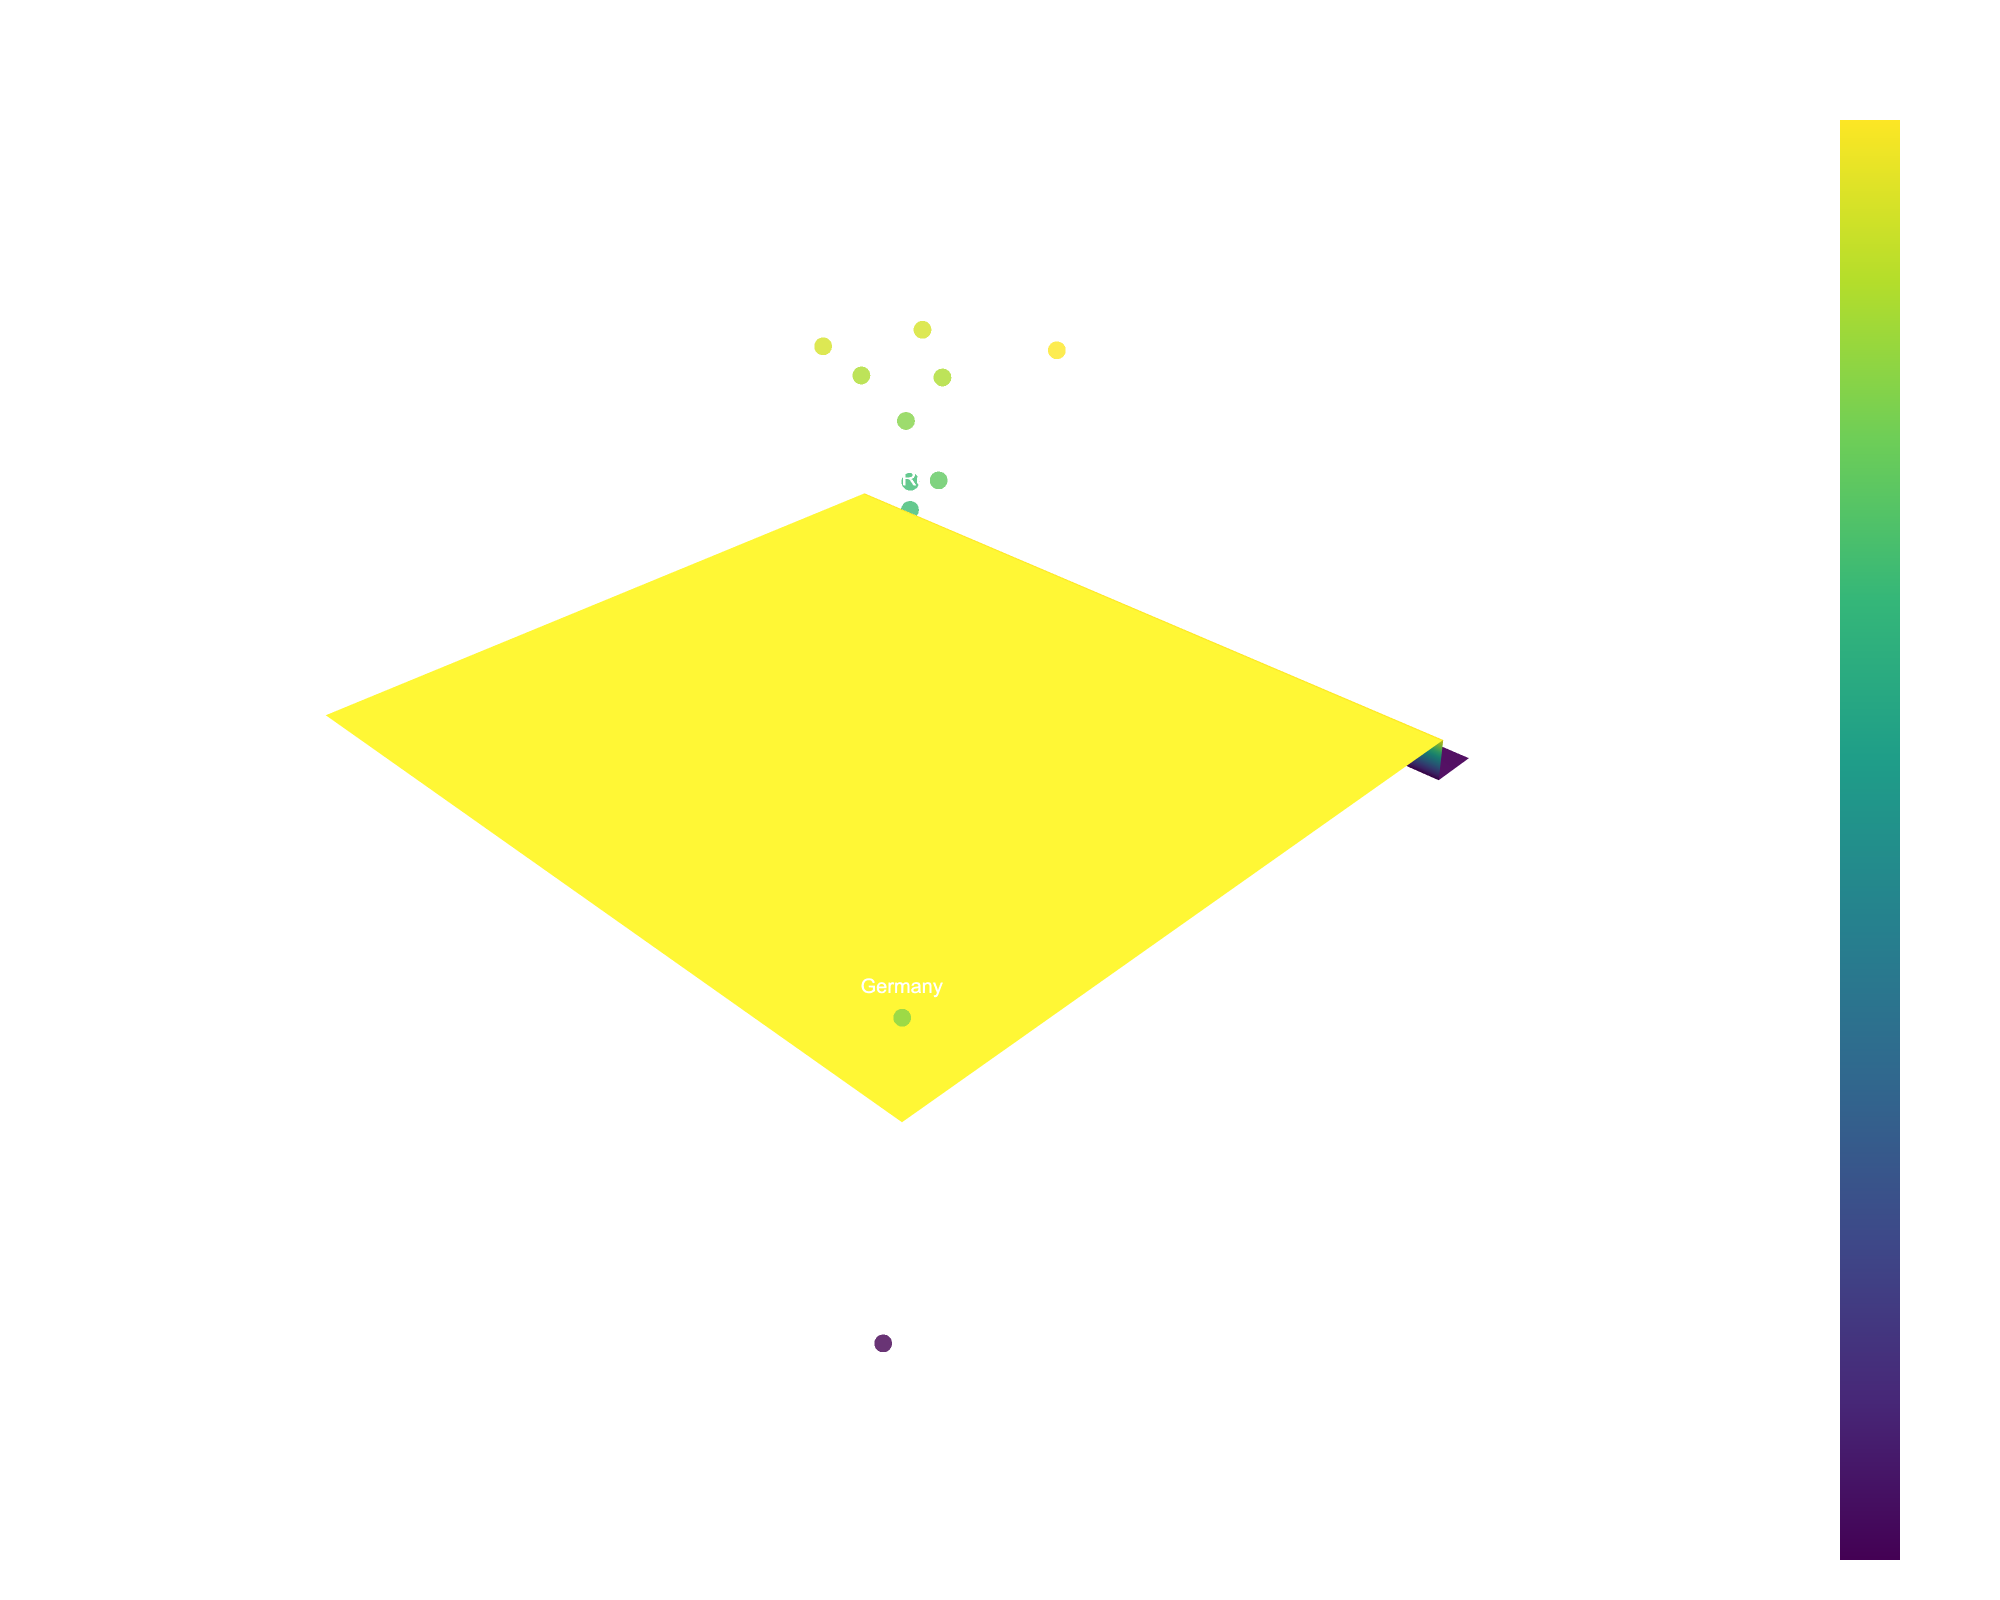what is the title of the figure? Reading the figure, you can see the title is displayed at the top. It helps provide an overview of what the figure is showing.
Answer: Electoral System Proportionality in European Countries How many countries are represented in the plot? The plot includes scatter points each representing a country, making it possible to count these points to determine the number of represented countries.
Answer: 15 Which country has the highest proportionality index? The proportionality index is shown on the vertical axis, and the highest point corresponds to Sweden.
Answer: Sweden Which variable does the x-axis represent? The x-axis is labeled and it indicates the variable being represented. In this plot, it is labeled "Population (millions)."
Answer: Population (millions) What relationship can be inferred between the number of seats and the proportionality index? By examining the scatter points along the number of seats (y-axis) and their corresponding proportionality index (z-axis), one can observe if there is an upward or downward trend. Higher number of seats typically lead to a higher proportionality index.
Answer: More seats often result in a higher proportionality index Which country has the smallest population among the represented countries? By examining the points on the x-axis, the country with the value closest to the minimum end of the axis represents the smallest population.
Answer: Ireland How do the proportionality indexes of Germany and Spain compare? By locating the positions of Germany and Spain on the plot and comparing their z-axis values (proportionality index), it is clear that Germany has a slightly higher proportionality index than Spain.
Answer: Germany has a higher proportionality index than Spain Is there a noticeable pattern in proportionality index with increasing population size? Observing the surface and scatter points along the x-axis (population size) and corresponding z-axis values (proportionality index) shows whether there's a visible trend or pattern. There isn't a strong visible pattern linking population size to proportionality index in this plot, though a higher population does not guarantee a directly proportional index.
Answer: No strong pattern What is the approximate proportionality index value for France? By locating France on the plot and evaluating its position along the z-axis, you can approximate its proportionality index value. It appears to be close to 0.82.
Answer: 0.82 